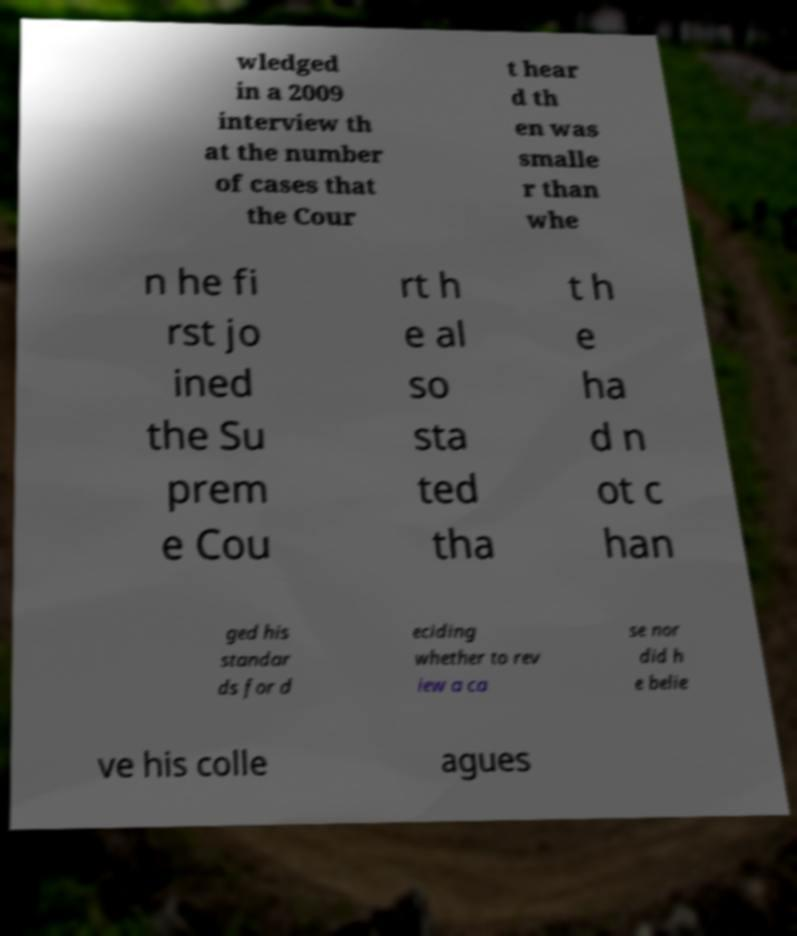Please identify and transcribe the text found in this image. wledged in a 2009 interview th at the number of cases that the Cour t hear d th en was smalle r than whe n he fi rst jo ined the Su prem e Cou rt h e al so sta ted tha t h e ha d n ot c han ged his standar ds for d eciding whether to rev iew a ca se nor did h e belie ve his colle agues 